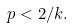<formula> <loc_0><loc_0><loc_500><loc_500>p < 2 / k .</formula> 